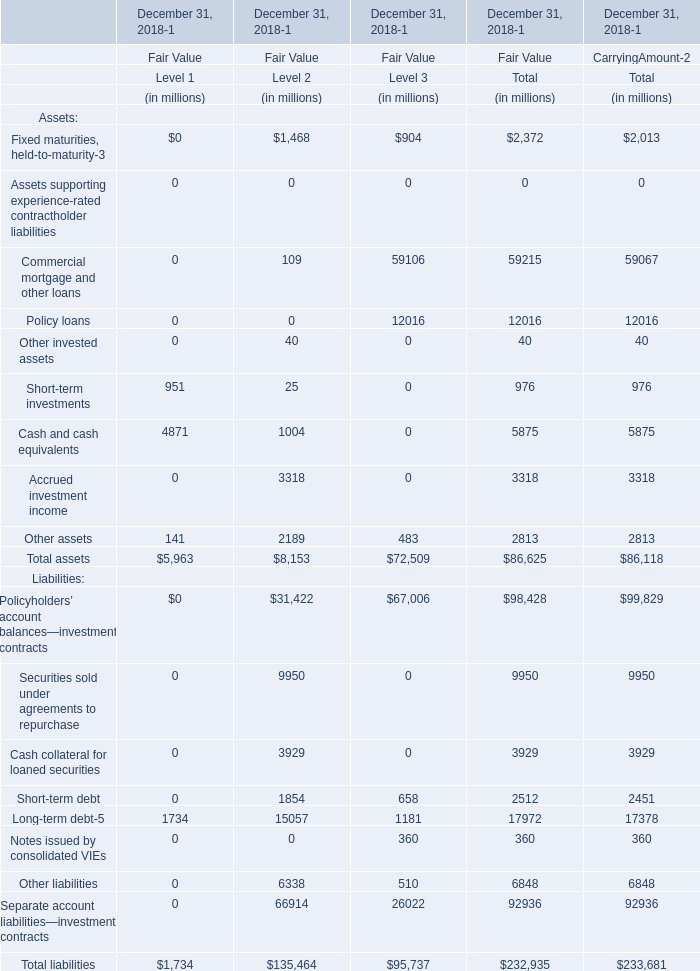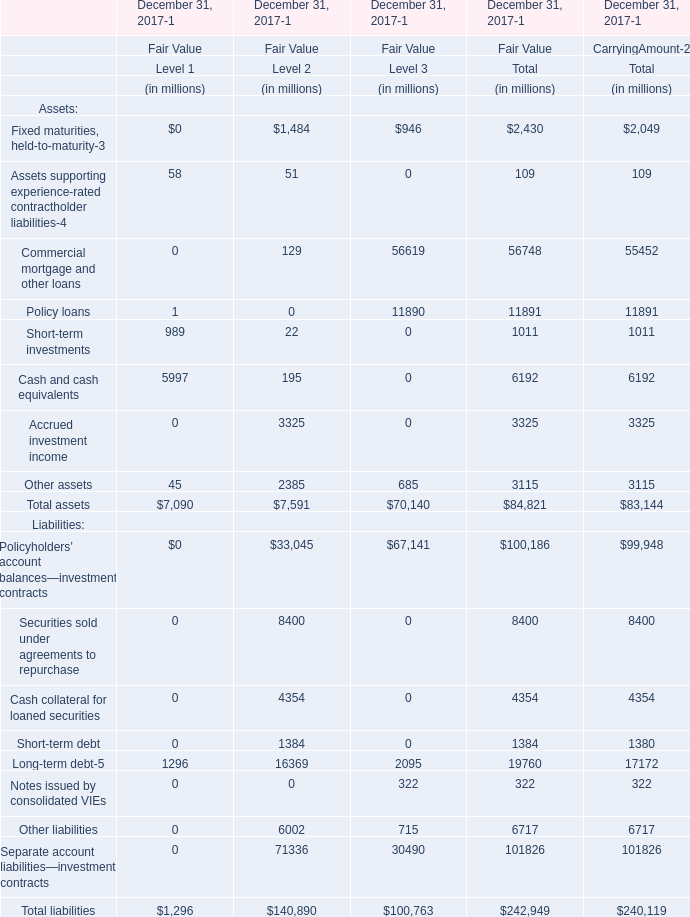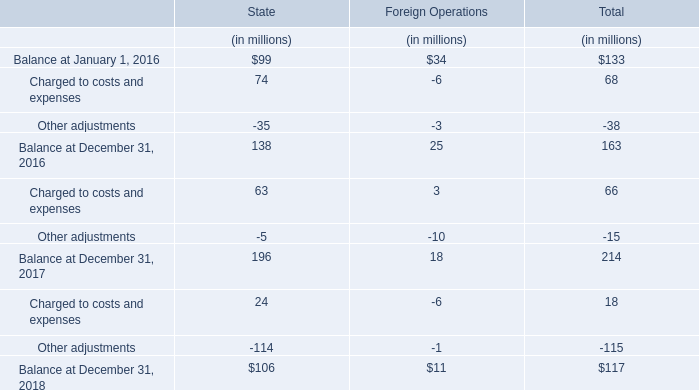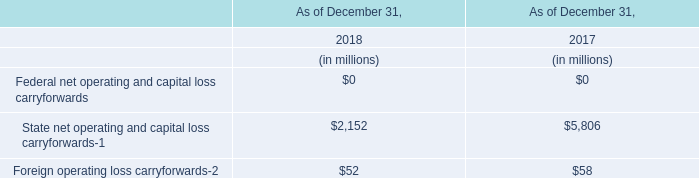What's the sum of all Level 1 that are positive in 2017 for Fair Value for December 31, 2017-1? (in million) 
Computations: (((((58 + 989) + 5997) + 45) + 1296) + 1)
Answer: 8386.0. 